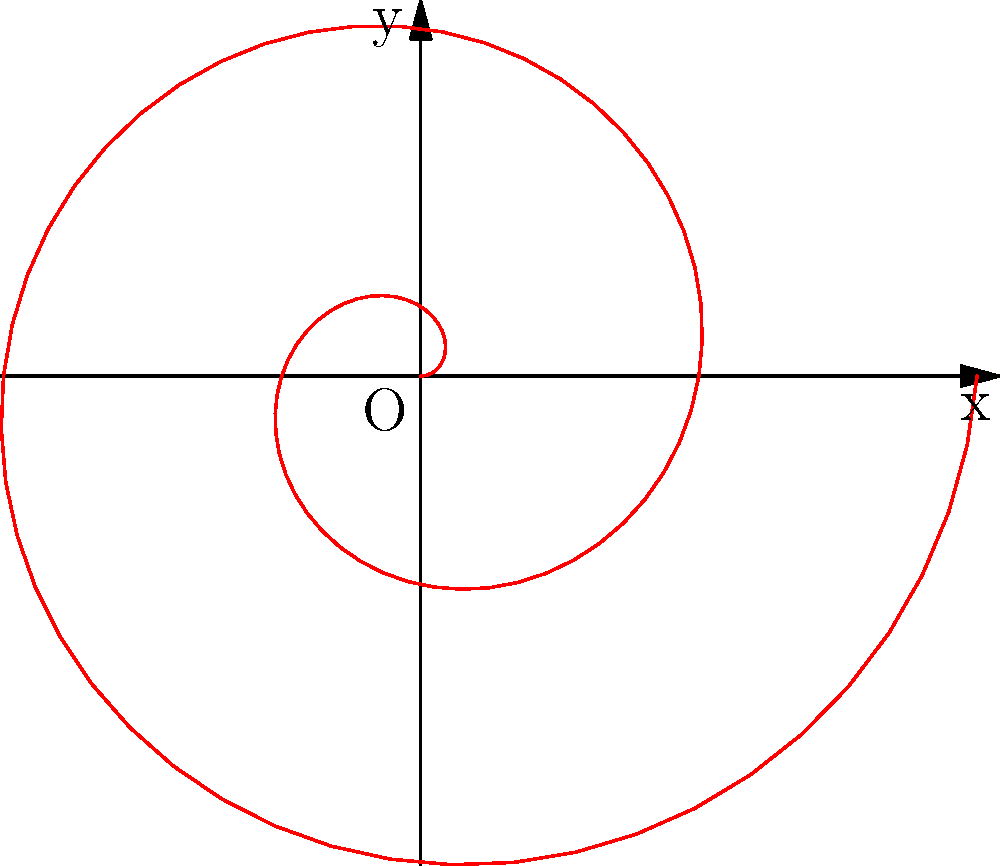A client has requested a spiral-shaped logo design for a custom promotional item. The spiral is defined by the polar equation $r = 0.2\theta$, where $r$ is in inches and $\theta$ is in radians. Calculate the area enclosed by the spiral for $0 \leq \theta \leq 4\pi$. To calculate the area enclosed by the spiral, we'll use the formula for area in polar coordinates:

$$A = \frac{1}{2} \int_a^b r^2(\theta) d\theta$$

Where $r(\theta) = 0.2\theta$ and we're integrating from $a = 0$ to $b = 4\pi$.

Step 1: Substitute $r(\theta)$ into the area formula:
$$A = \frac{1}{2} \int_0^{4\pi} (0.2\theta)^2 d\theta$$

Step 2: Simplify the integrand:
$$A = \frac{1}{2} \int_0^{4\pi} 0.04\theta^2 d\theta$$

Step 3: Integrate:
$$A = \frac{1}{2} \cdot 0.04 \cdot \left[\frac{1}{3}\theta^3\right]_0^{4\pi}$$

Step 4: Evaluate the integral:
$$A = 0.02 \cdot \left[\frac{1}{3}(4\pi)^3 - \frac{1}{3}(0)^3\right]$$
$$A = 0.02 \cdot \frac{1}{3}(64\pi^3)$$
$$A = \frac{64\pi^3}{150} \approx 8.46 \text{ square inches}$$

Therefore, the area enclosed by the spiral logo is approximately 8.46 square inches.
Answer: $\frac{64\pi^3}{150}$ sq in ($\approx 8.46$ sq in) 